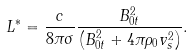Convert formula to latex. <formula><loc_0><loc_0><loc_500><loc_500>L ^ { \ast } = \frac { c } { 8 \pi \sigma } \frac { B _ { 0 t } ^ { 2 } } { \left ( B _ { 0 t } ^ { 2 } + 4 \pi \rho _ { 0 } v _ { s } ^ { 2 } \right ) } .</formula> 